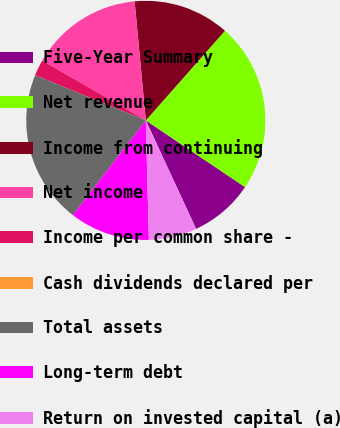Convert chart to OTSL. <chart><loc_0><loc_0><loc_500><loc_500><pie_chart><fcel>Five-Year Summary<fcel>Net revenue<fcel>Income from continuing<fcel>Net income<fcel>Income per common share -<fcel>Cash dividends declared per<fcel>Total assets<fcel>Long-term debt<fcel>Return on invested capital (a)<nl><fcel>8.67%<fcel>22.9%<fcel>13.01%<fcel>15.17%<fcel>2.17%<fcel>0.0%<fcel>20.73%<fcel>10.84%<fcel>6.5%<nl></chart> 